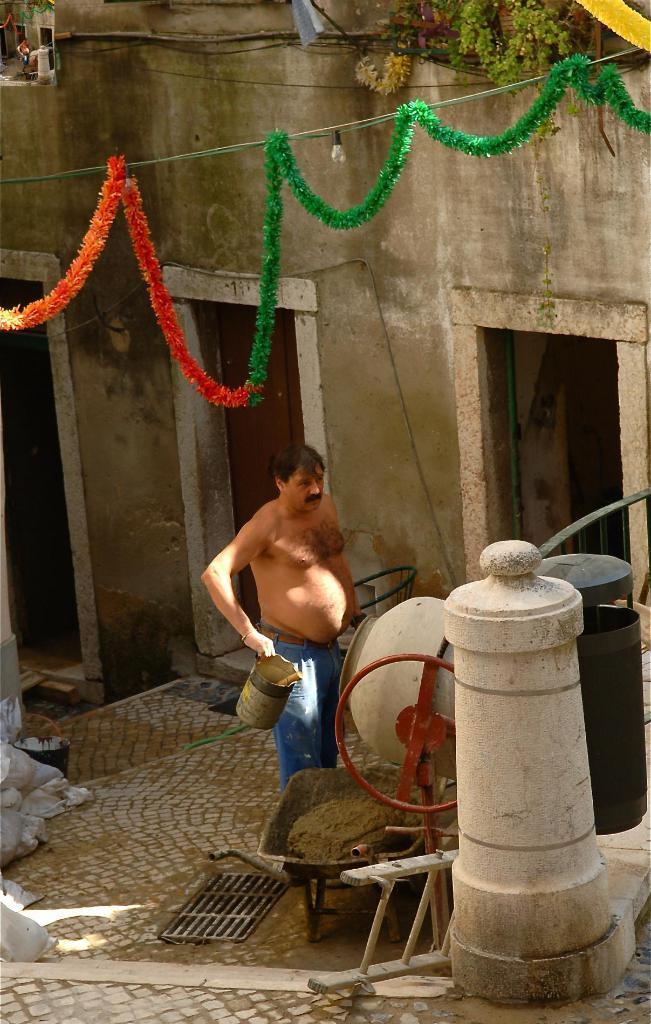In one or two sentences, can you explain what this image depicts? In this image there is a person holding an object in his hand, in front of him there is an equipment, below that there are few objects on the surface, In the background there is a wall with doors, at the top of the image there is a decoration and some plant pots. 